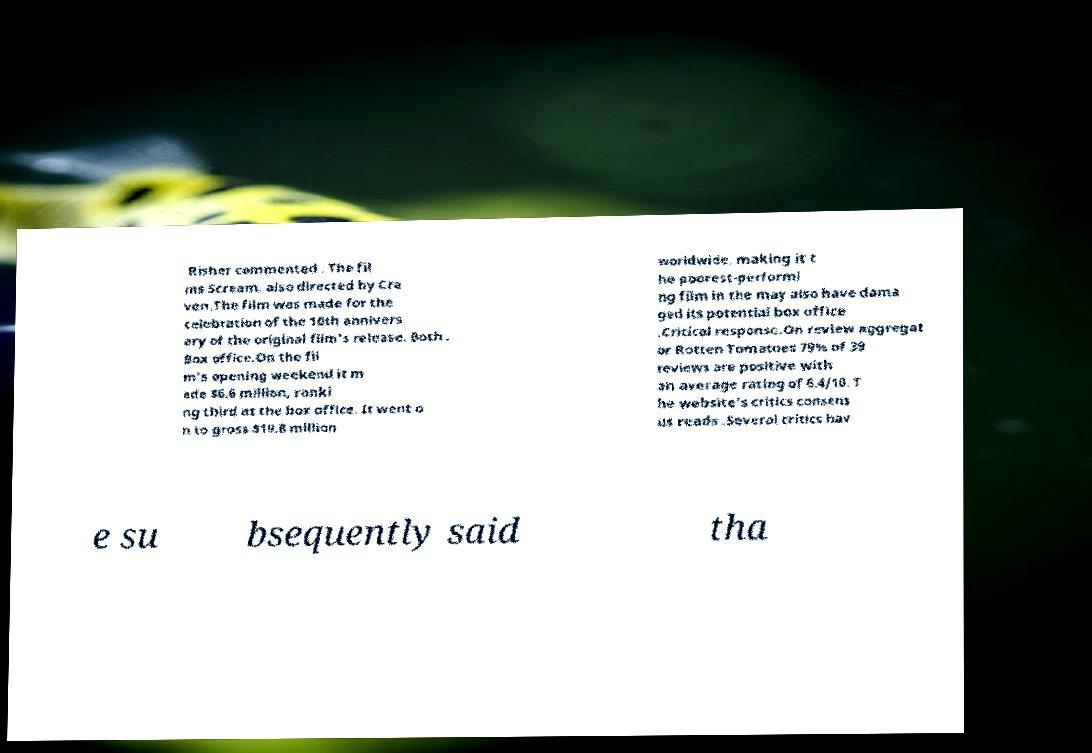Can you accurately transcribe the text from the provided image for me? Risher commented . The fil ms Scream, also directed by Cra ven.The film was made for the celebration of the 10th annivers ary of the original film's release. Both . Box office.On the fil m's opening weekend it m ade $6.6 million, ranki ng third at the box office. It went o n to gross $19.8 million worldwide, making it t he poorest-performi ng film in the may also have dama ged its potential box office .Critical response.On review aggregat or Rotten Tomatoes 79% of 39 reviews are positive with an average rating of 6.4/10. T he website's critics consens us reads .Several critics hav e su bsequently said tha 